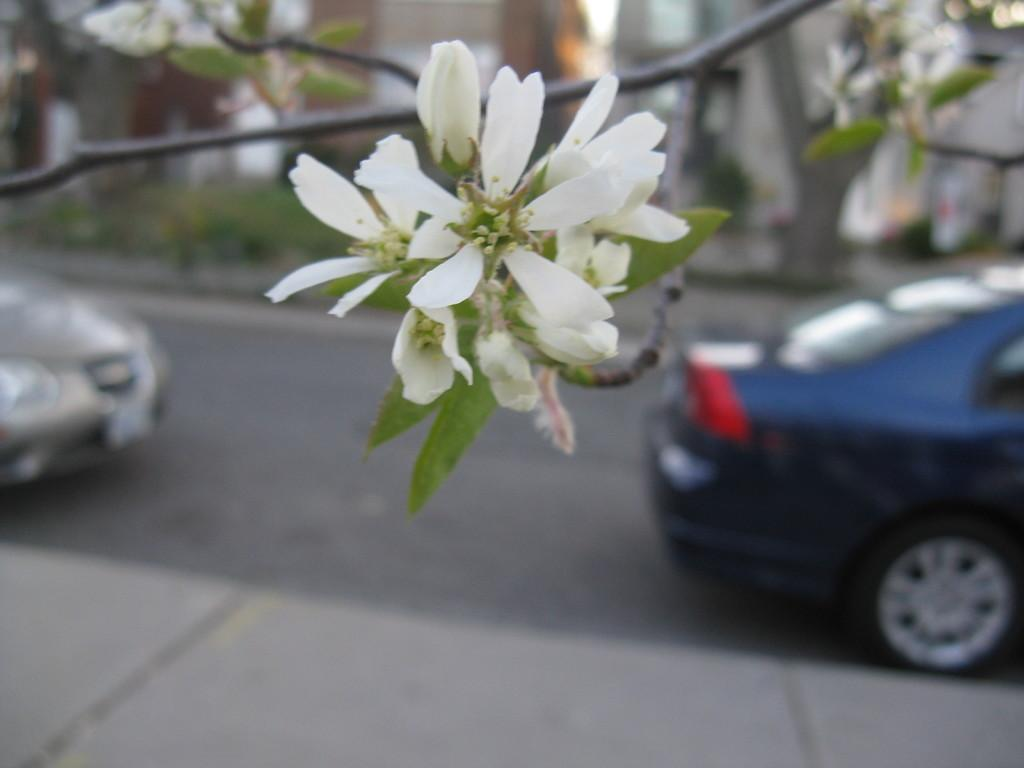What type of plant is present in the image? There are flowers on a plant in the image. What can be seen on the road in the image? There are vehicles visible on the road in the image. What is located in the background of the image? There is a building in the background of the image. How many spots can be seen on the building in the image? There are no spots mentioned or visible on the building in the image. What type of pin is used to measure the distance between the vehicles in the image? There is no pin present in the image, and no measurements are being taken. 